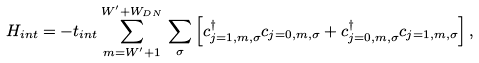<formula> <loc_0><loc_0><loc_500><loc_500>H _ { i n t } = - t _ { i n t } \sum _ { m = W ^ { \prime } + 1 } ^ { W ^ { \prime } + W _ { D N } } \, \sum _ { \sigma } \left [ c ^ { \dagger } _ { j = 1 , m , \sigma } c _ { j = 0 , m , \sigma } + c ^ { \dagger } _ { j = 0 , m , \sigma } c _ { j = 1 , m , \sigma } \right ] ,</formula> 